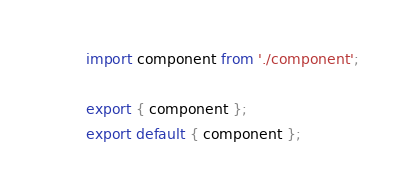<code> <loc_0><loc_0><loc_500><loc_500><_JavaScript_>import component from './component';

export { component };
export default { component };</code> 